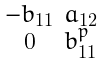Convert formula to latex. <formula><loc_0><loc_0><loc_500><loc_500>\begin{smallmatrix} - b _ { 1 1 } & a _ { 1 2 } \\ 0 & b _ { 1 1 } ^ { p } \end{smallmatrix}</formula> 